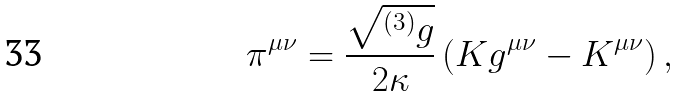Convert formula to latex. <formula><loc_0><loc_0><loc_500><loc_500>\pi ^ { \mu \nu } = \frac { \sqrt { ^ { \left ( 3 \right ) } g } } { 2 \kappa } \left ( K g ^ { \mu \nu } - K ^ { \mu \nu } \right ) ,</formula> 